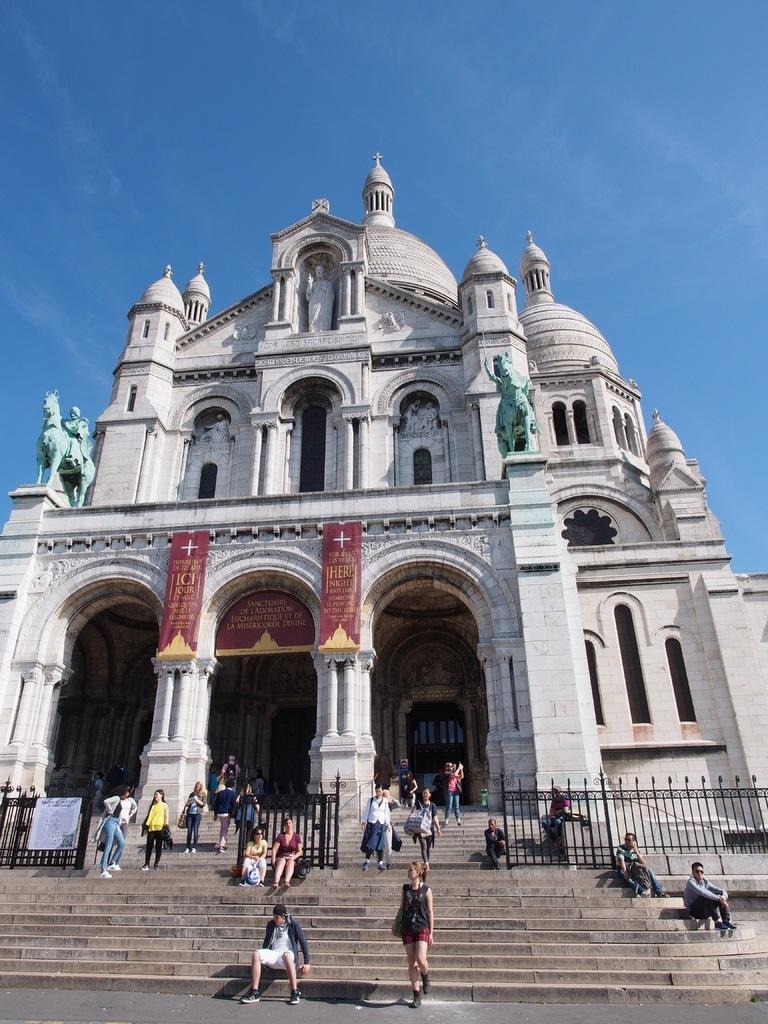What type of structure is visible in the image? There is a building in the image. Are there any additional features near the building? Yes, there are statues near the building. What are the people in the image doing? The people in the image are sitting on the staircase in front of the building. What type of barrier is present in the image? There is some fencing in the image. What type of waves can be seen crashing against the building in the image? There are no waves present in the image; it features a building with statues, people, and fencing. 